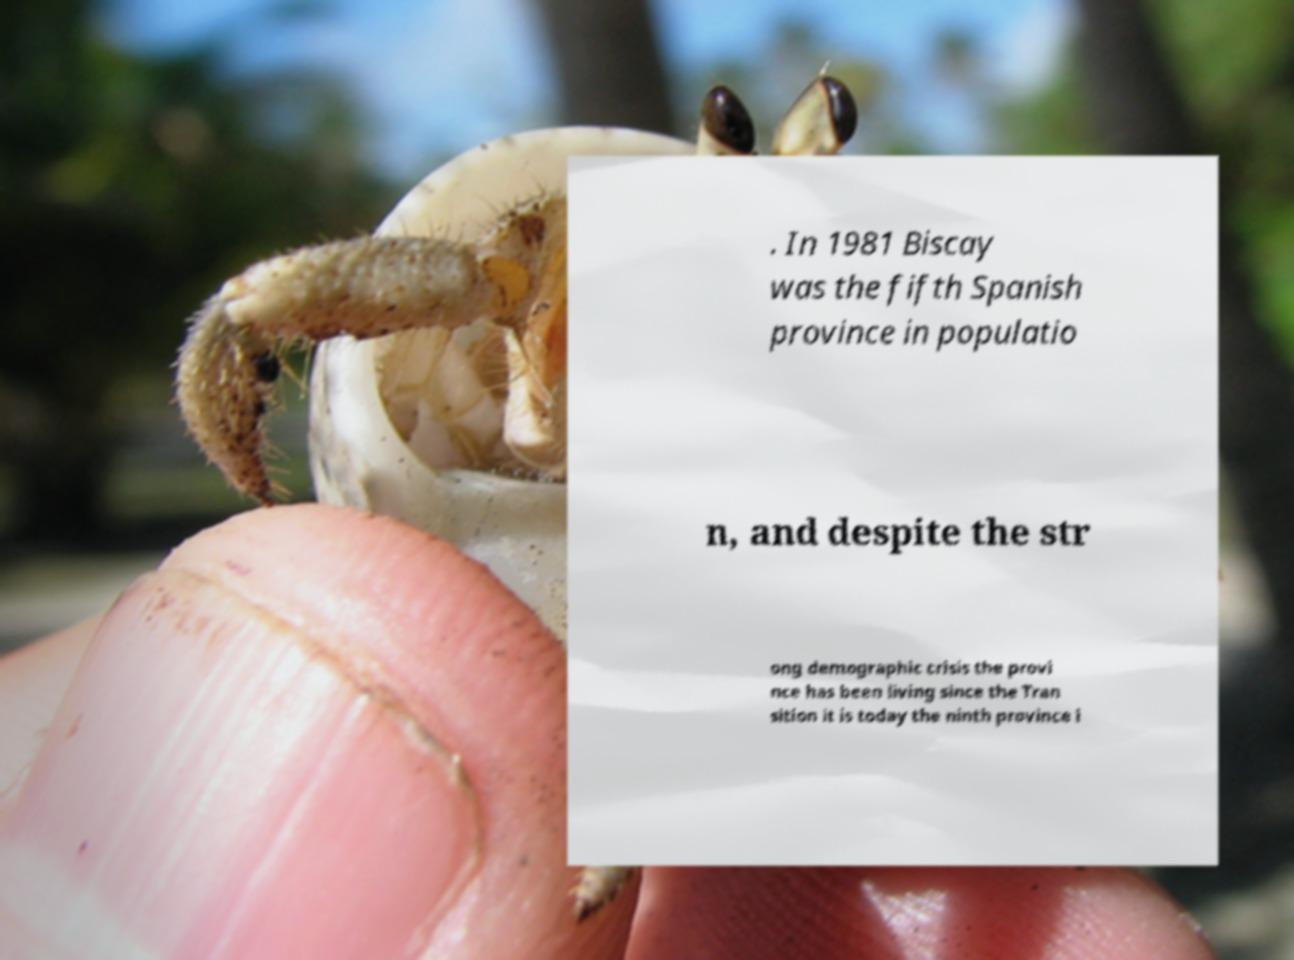For documentation purposes, I need the text within this image transcribed. Could you provide that? . In 1981 Biscay was the fifth Spanish province in populatio n, and despite the str ong demographic crisis the provi nce has been living since the Tran sition it is today the ninth province i 